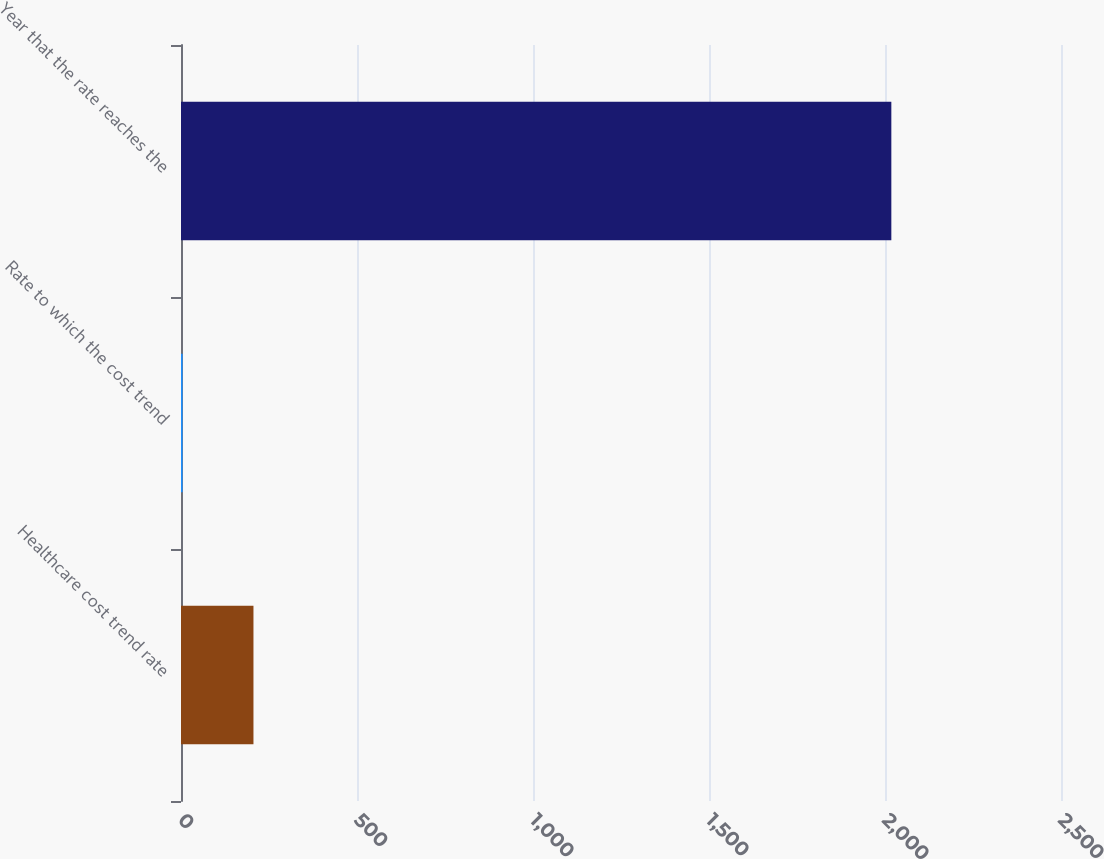<chart> <loc_0><loc_0><loc_500><loc_500><bar_chart><fcel>Healthcare cost trend rate<fcel>Rate to which the cost trend<fcel>Year that the rate reaches the<nl><fcel>205.85<fcel>4.5<fcel>2018<nl></chart> 